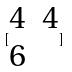Convert formula to latex. <formula><loc_0><loc_0><loc_500><loc_500>[ \begin{matrix} 4 & 4 \\ 6 \end{matrix} ]</formula> 